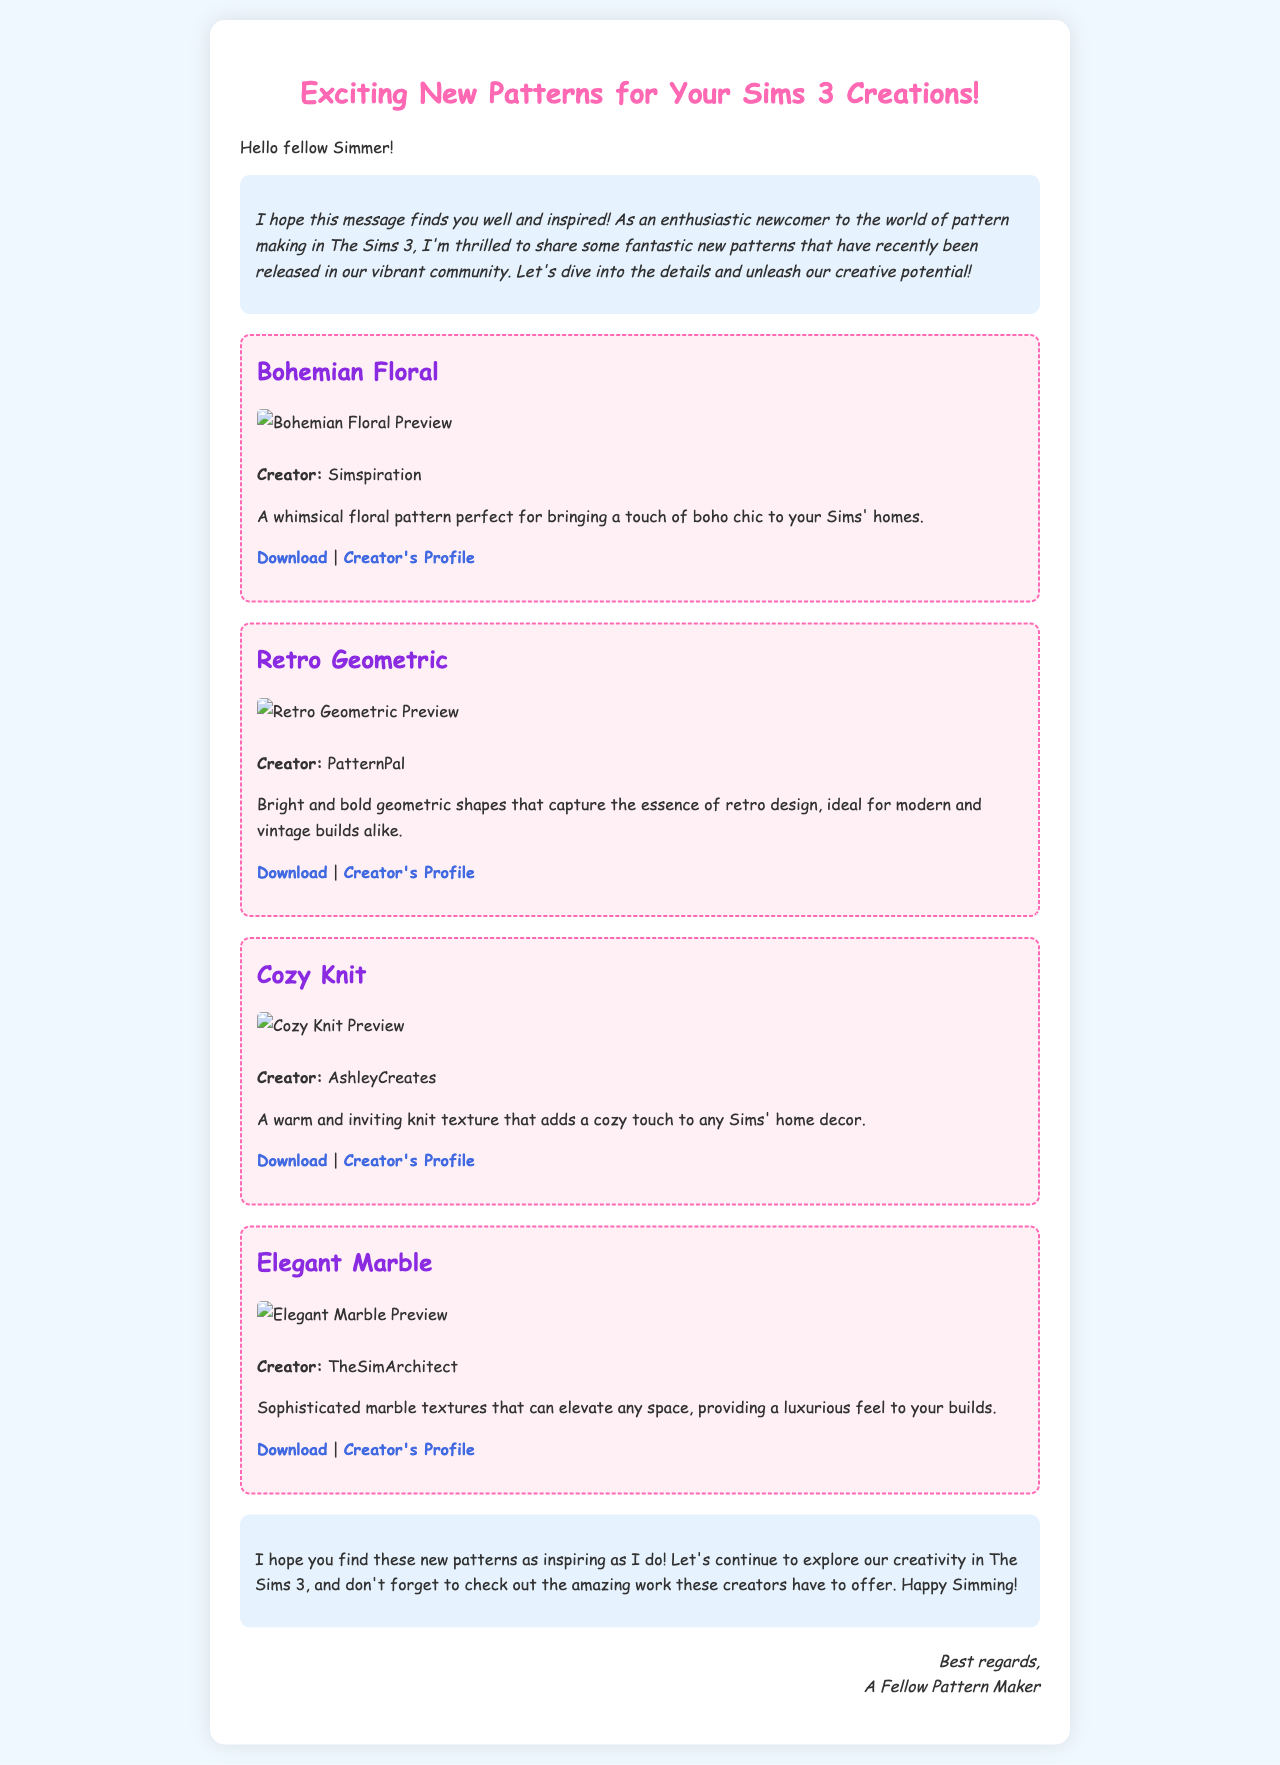What is the name of the first pattern listed? The first pattern is labeled as "Bohemian Floral."
Answer: Bohemian Floral Who is the creator of the "Elegant Marble" pattern? The document states that "Elegant Marble" is created by TheSimArchitect.
Answer: TheSimArchitect How many patterns are featured in the document? The document displays a total of four distinct patterns.
Answer: Four What unique feature do all patterns shared in the document have? Each pattern description includes a download link and a creator's profile link.
Answer: Download link and creator's profile Which pattern is described as warm and inviting? The "Cozy Knit" pattern is specifically described with such attributes.
Answer: Cozy Knit What color scheme does the introduction background have? The introduction section uses a light blue background color.
Answer: Light blue What type of font is used throughout the email? The email utilizes 'Comic Sans MS' as its primary font style.
Answer: Comic Sans MS What is the closing message encouraging readers to do? The closing message encourages readers to continue exploring their creativity in The Sims 3.
Answer: Explore creativity What kind of visual representation accompanies each pattern? Each pattern features a preview image for visual representation.
Answer: Preview image 